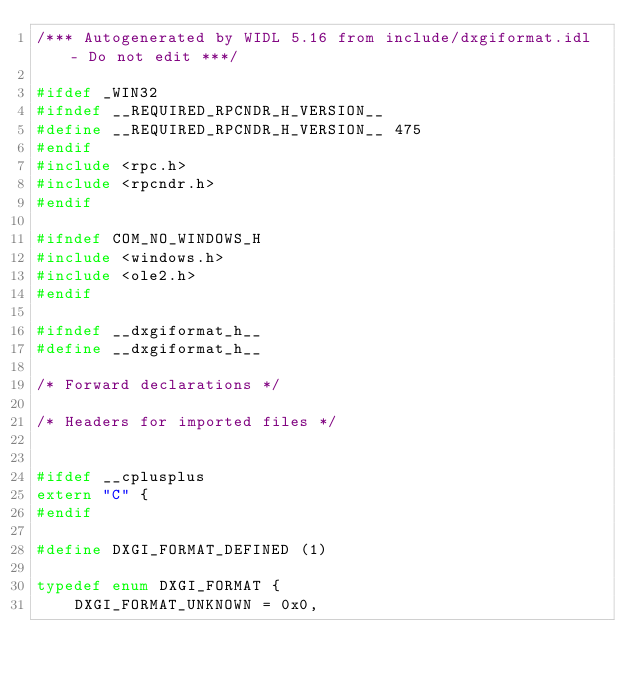<code> <loc_0><loc_0><loc_500><loc_500><_C_>/*** Autogenerated by WIDL 5.16 from include/dxgiformat.idl - Do not edit ***/

#ifdef _WIN32
#ifndef __REQUIRED_RPCNDR_H_VERSION__
#define __REQUIRED_RPCNDR_H_VERSION__ 475
#endif
#include <rpc.h>
#include <rpcndr.h>
#endif

#ifndef COM_NO_WINDOWS_H
#include <windows.h>
#include <ole2.h>
#endif

#ifndef __dxgiformat_h__
#define __dxgiformat_h__

/* Forward declarations */

/* Headers for imported files */


#ifdef __cplusplus
extern "C" {
#endif

#define DXGI_FORMAT_DEFINED (1)

typedef enum DXGI_FORMAT {
    DXGI_FORMAT_UNKNOWN = 0x0,</code> 